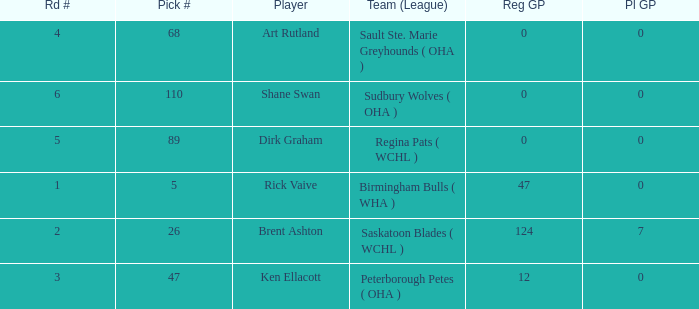How many rounds exist for picks under 5? 0.0. 